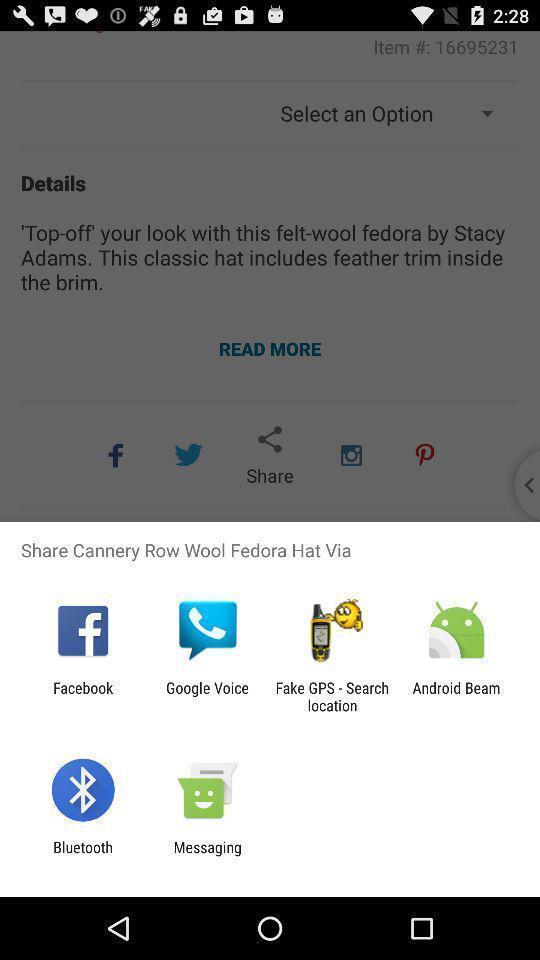Describe this image in words. Popup shows different apps to share. 